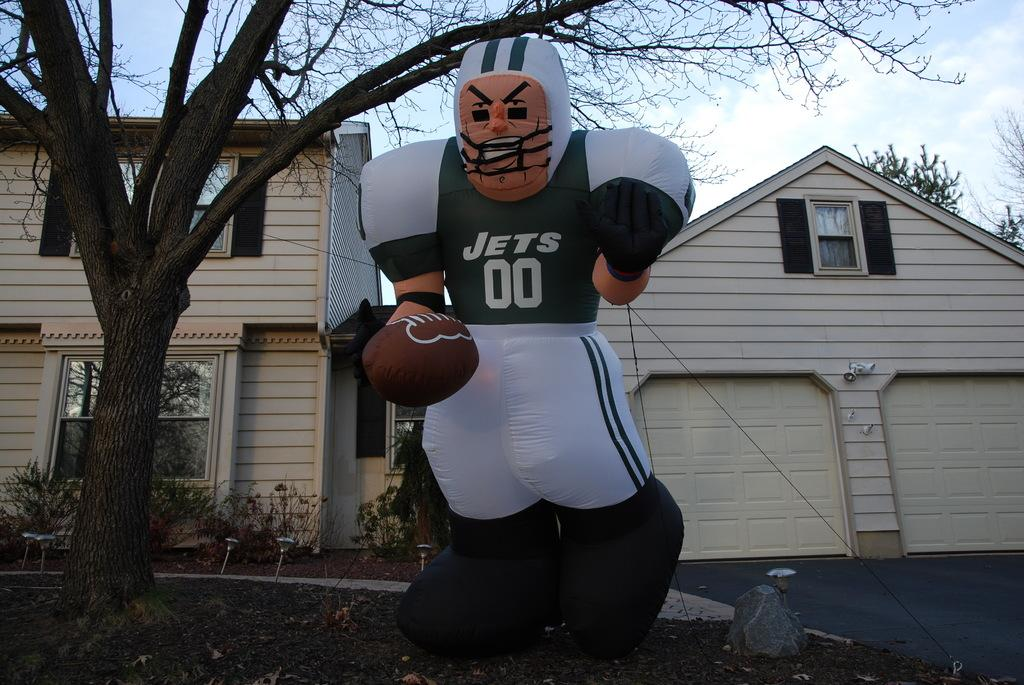<image>
Offer a succinct explanation of the picture presented. A football player Jets 00 large decorative balloon ornament is placed on a front lawn. 